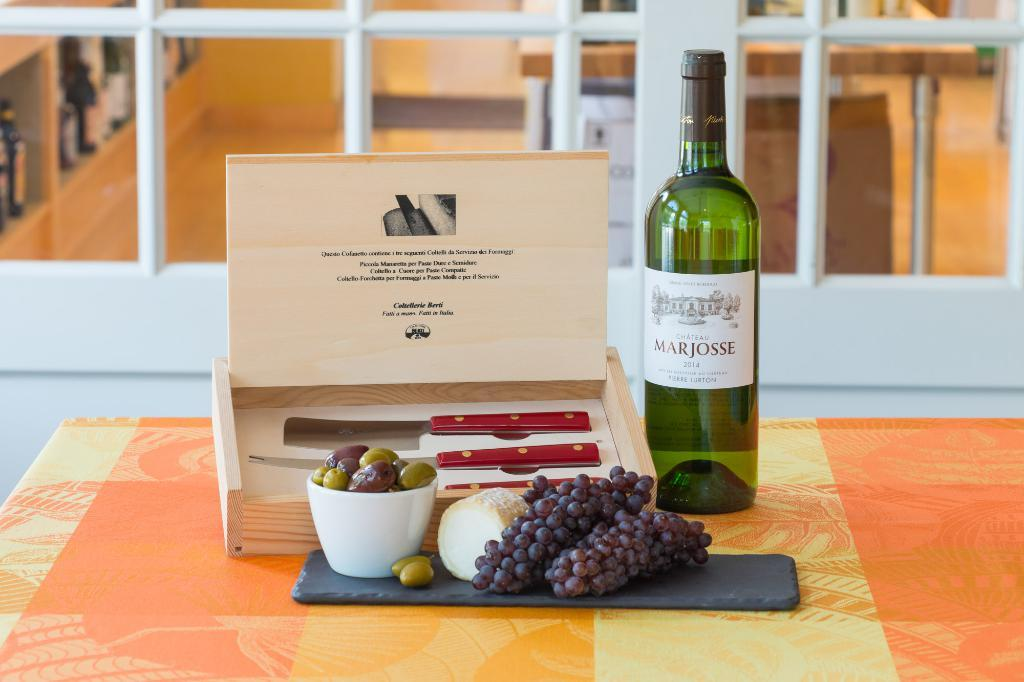<image>
Give a short and clear explanation of the subsequent image. A bottle of Marjosse wine sits near a box and some grapes. 